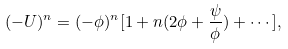Convert formula to latex. <formula><loc_0><loc_0><loc_500><loc_500>( - U ) ^ { n } = ( - \phi ) ^ { n } [ 1 + n ( 2 \phi + \frac { \psi } { \phi } ) + \cdots ] ,</formula> 